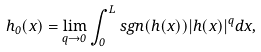Convert formula to latex. <formula><loc_0><loc_0><loc_500><loc_500>h _ { 0 } ( x ) = \lim _ { q \rightarrow 0 } \int _ { 0 } ^ { L } s g n ( h ( x ) ) | h ( x ) | ^ { q } d x ,</formula> 